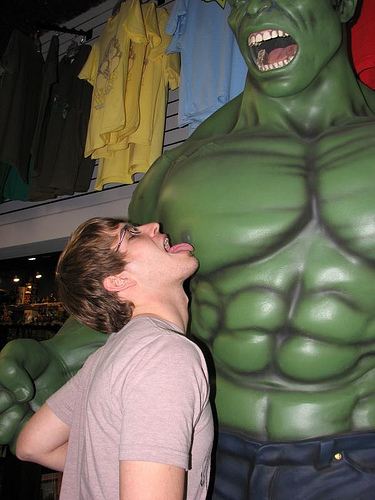<image>
Is there a hulk on the guy? No. The hulk is not positioned on the guy. They may be near each other, but the hulk is not supported by or resting on top of the guy. 